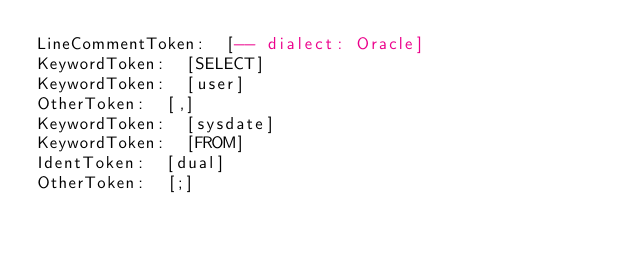Convert code to text. <code><loc_0><loc_0><loc_500><loc_500><_SQL_>LineCommentToken:  [-- dialect: Oracle]
KeywordToken:  [SELECT]
KeywordToken:  [user]
OtherToken:  [,]
KeywordToken:  [sysdate]
KeywordToken:  [FROM]
IdentToken:  [dual]
OtherToken:  [;]
</code> 